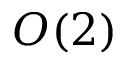<formula> <loc_0><loc_0><loc_500><loc_500>O ( 2 )</formula> 